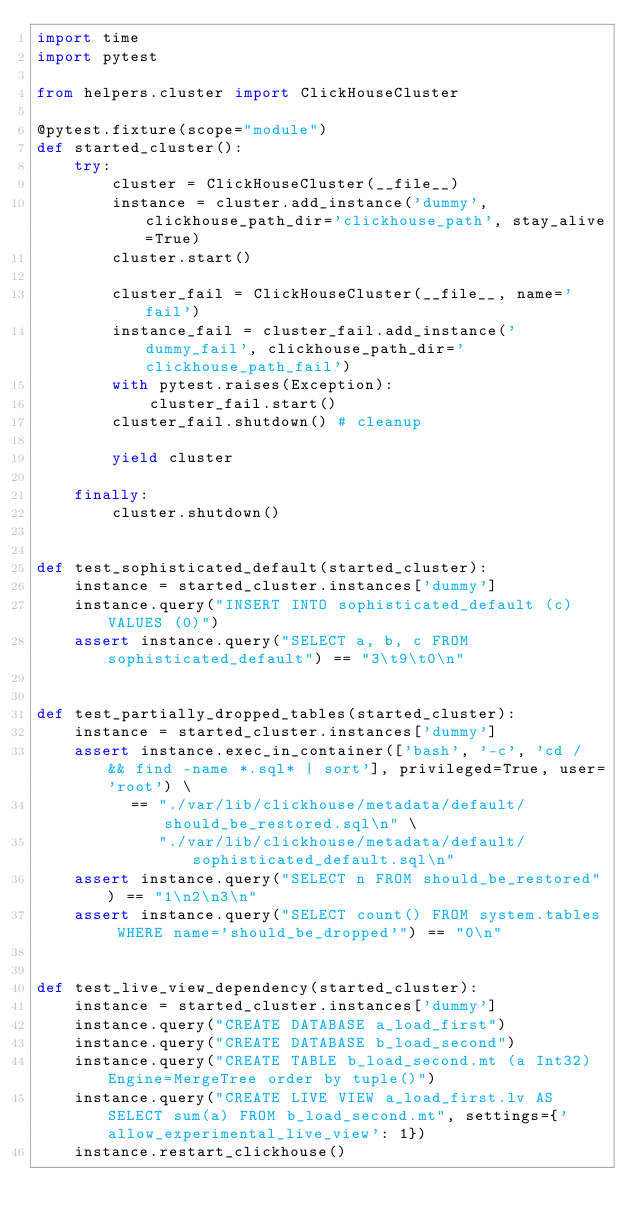Convert code to text. <code><loc_0><loc_0><loc_500><loc_500><_Python_>import time
import pytest

from helpers.cluster import ClickHouseCluster

@pytest.fixture(scope="module")
def started_cluster():
    try:
        cluster = ClickHouseCluster(__file__)
        instance = cluster.add_instance('dummy', clickhouse_path_dir='clickhouse_path', stay_alive=True)
        cluster.start()

        cluster_fail = ClickHouseCluster(__file__, name='fail')
        instance_fail = cluster_fail.add_instance('dummy_fail', clickhouse_path_dir='clickhouse_path_fail')
        with pytest.raises(Exception):
            cluster_fail.start()
        cluster_fail.shutdown() # cleanup

        yield cluster

    finally:
        cluster.shutdown()


def test_sophisticated_default(started_cluster):
    instance = started_cluster.instances['dummy']
    instance.query("INSERT INTO sophisticated_default (c) VALUES (0)")
    assert instance.query("SELECT a, b, c FROM sophisticated_default") == "3\t9\t0\n"


def test_partially_dropped_tables(started_cluster):
    instance = started_cluster.instances['dummy']
    assert instance.exec_in_container(['bash', '-c', 'cd / && find -name *.sql* | sort'], privileged=True, user='root') \
          == "./var/lib/clickhouse/metadata/default/should_be_restored.sql\n" \
             "./var/lib/clickhouse/metadata/default/sophisticated_default.sql\n"
    assert instance.query("SELECT n FROM should_be_restored") == "1\n2\n3\n"
    assert instance.query("SELECT count() FROM system.tables WHERE name='should_be_dropped'") == "0\n"


def test_live_view_dependency(started_cluster):
    instance = started_cluster.instances['dummy']
    instance.query("CREATE DATABASE a_load_first")
    instance.query("CREATE DATABASE b_load_second")
    instance.query("CREATE TABLE b_load_second.mt (a Int32) Engine=MergeTree order by tuple()")
    instance.query("CREATE LIVE VIEW a_load_first.lv AS SELECT sum(a) FROM b_load_second.mt", settings={'allow_experimental_live_view': 1})
    instance.restart_clickhouse()
</code> 